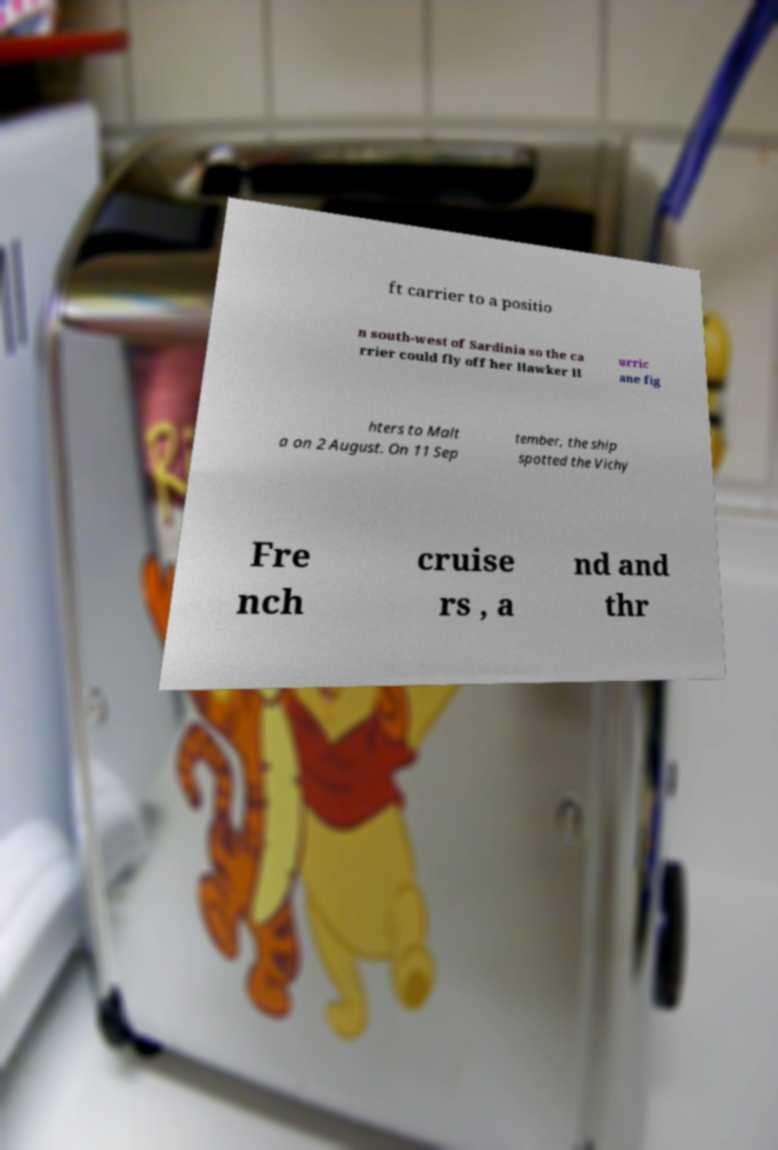Could you assist in decoding the text presented in this image and type it out clearly? ft carrier to a positio n south-west of Sardinia so the ca rrier could fly off her Hawker H urric ane fig hters to Malt a on 2 August. On 11 Sep tember, the ship spotted the Vichy Fre nch cruise rs , a nd and thr 